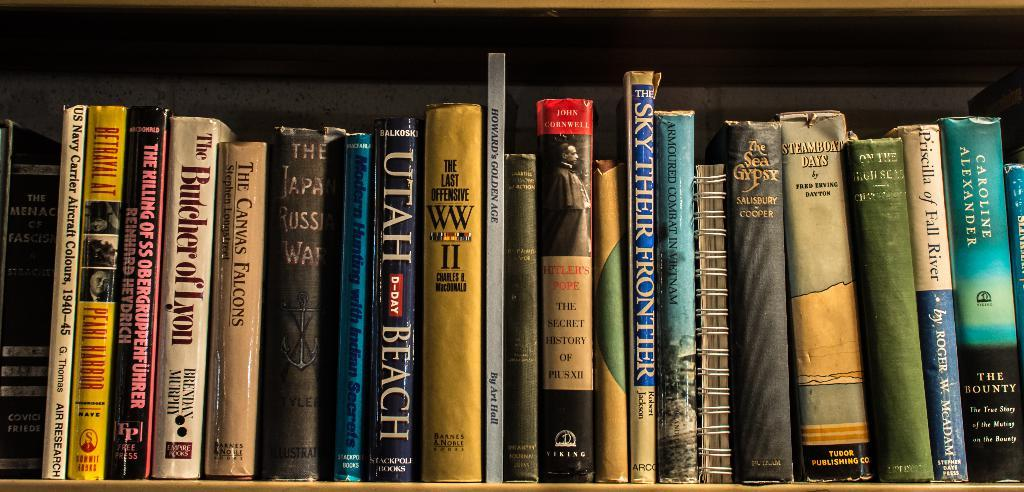Provide a one-sentence caption for the provided image. Many books such as The Butcher of Lyon are stacked on a bookshelf. 